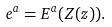Convert formula to latex. <formula><loc_0><loc_0><loc_500><loc_500>e ^ { a } = E ^ { a } ( Z ( z ) ) .</formula> 